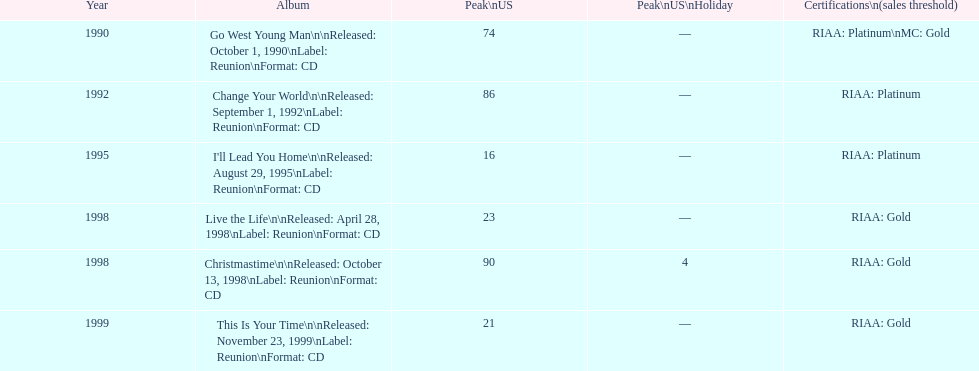Which album has the least peak in the us? I'll Lead You Home. 